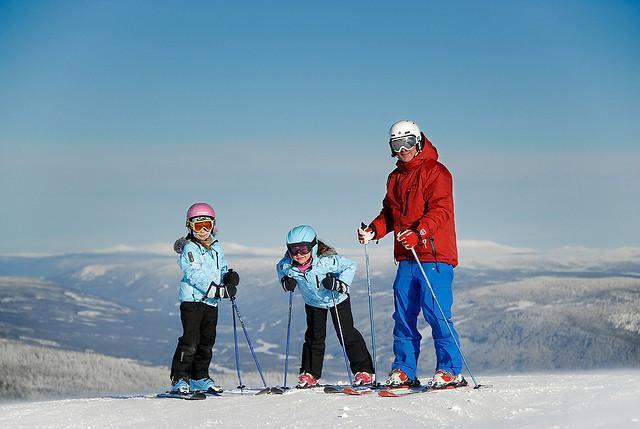How many kids in this photo?
Give a very brief answer. 2. How many people are there?
Give a very brief answer. 3. How many slices of pizza have been eaten?
Give a very brief answer. 0. 